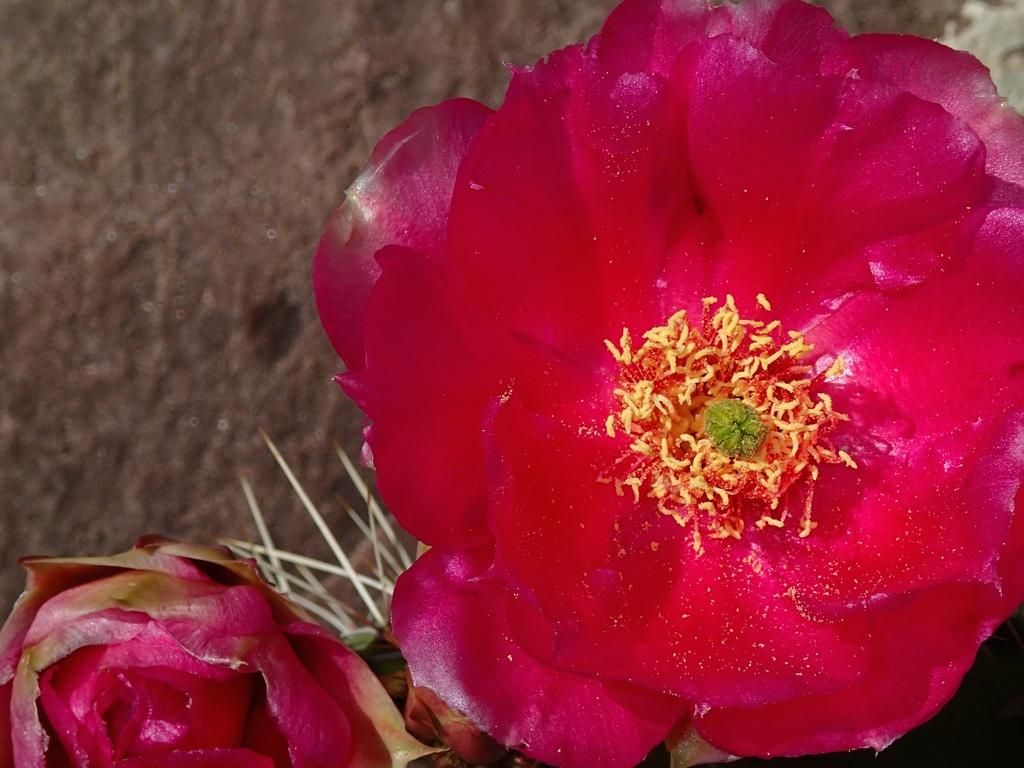What type of living organisms can be seen in the image? There are flowers in the image. What is the color of the flowers in the image? The flowers are red in color. Who is the owner of the art piece featuring the sister in the image? There is no art piece or sister present in the image, only red flowers. 